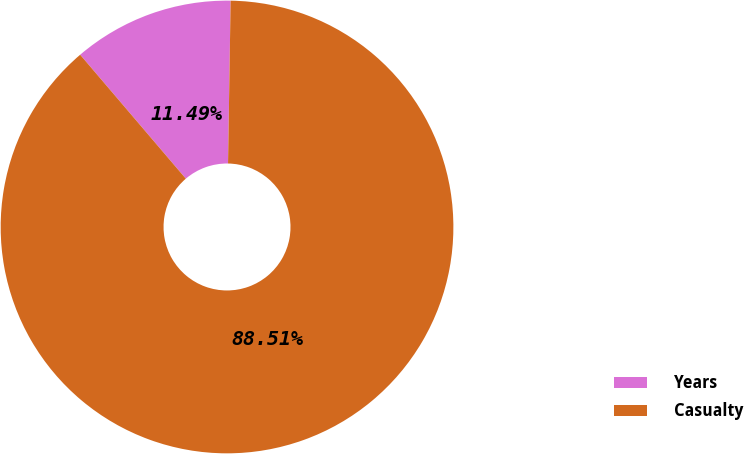<chart> <loc_0><loc_0><loc_500><loc_500><pie_chart><fcel>Years<fcel>Casualty<nl><fcel>11.49%<fcel>88.51%<nl></chart> 